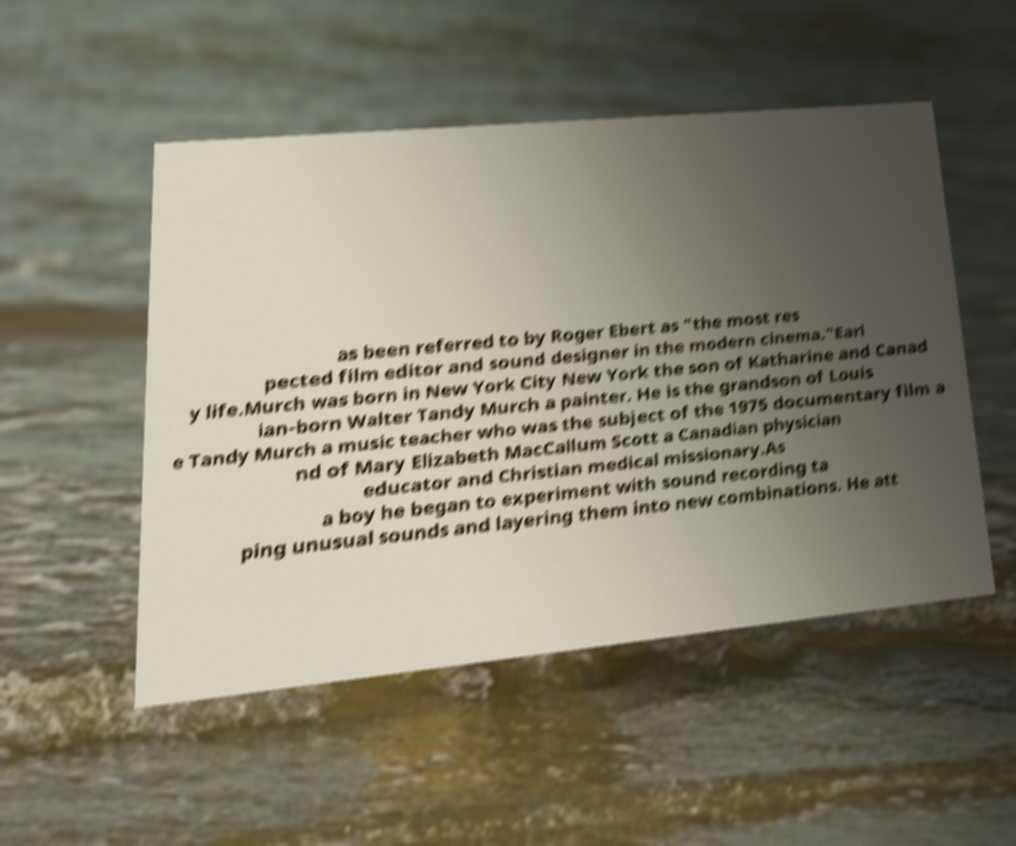Can you accurately transcribe the text from the provided image for me? as been referred to by Roger Ebert as "the most res pected film editor and sound designer in the modern cinema."Earl y life.Murch was born in New York City New York the son of Katharine and Canad ian-born Walter Tandy Murch a painter. He is the grandson of Louis e Tandy Murch a music teacher who was the subject of the 1975 documentary film a nd of Mary Elizabeth MacCallum Scott a Canadian physician educator and Christian medical missionary.As a boy he began to experiment with sound recording ta ping unusual sounds and layering them into new combinations. He att 